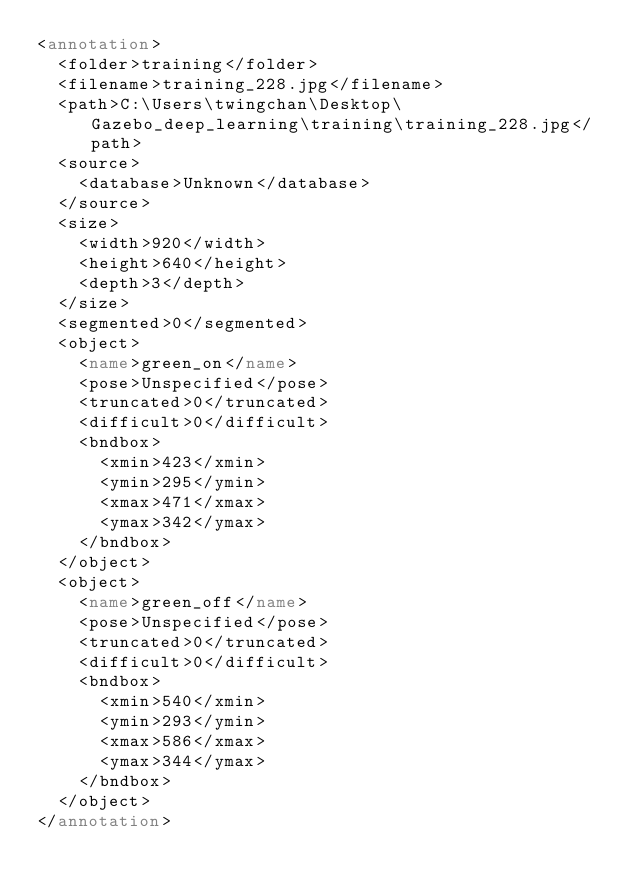<code> <loc_0><loc_0><loc_500><loc_500><_XML_><annotation>
	<folder>training</folder>
	<filename>training_228.jpg</filename>
	<path>C:\Users\twingchan\Desktop\Gazebo_deep_learning\training\training_228.jpg</path>
	<source>
		<database>Unknown</database>
	</source>
	<size>
		<width>920</width>
		<height>640</height>
		<depth>3</depth>
	</size>
	<segmented>0</segmented>
	<object>
		<name>green_on</name>
		<pose>Unspecified</pose>
		<truncated>0</truncated>
		<difficult>0</difficult>
		<bndbox>
			<xmin>423</xmin>
			<ymin>295</ymin>
			<xmax>471</xmax>
			<ymax>342</ymax>
		</bndbox>
	</object>
	<object>
		<name>green_off</name>
		<pose>Unspecified</pose>
		<truncated>0</truncated>
		<difficult>0</difficult>
		<bndbox>
			<xmin>540</xmin>
			<ymin>293</ymin>
			<xmax>586</xmax>
			<ymax>344</ymax>
		</bndbox>
	</object>
</annotation>
</code> 